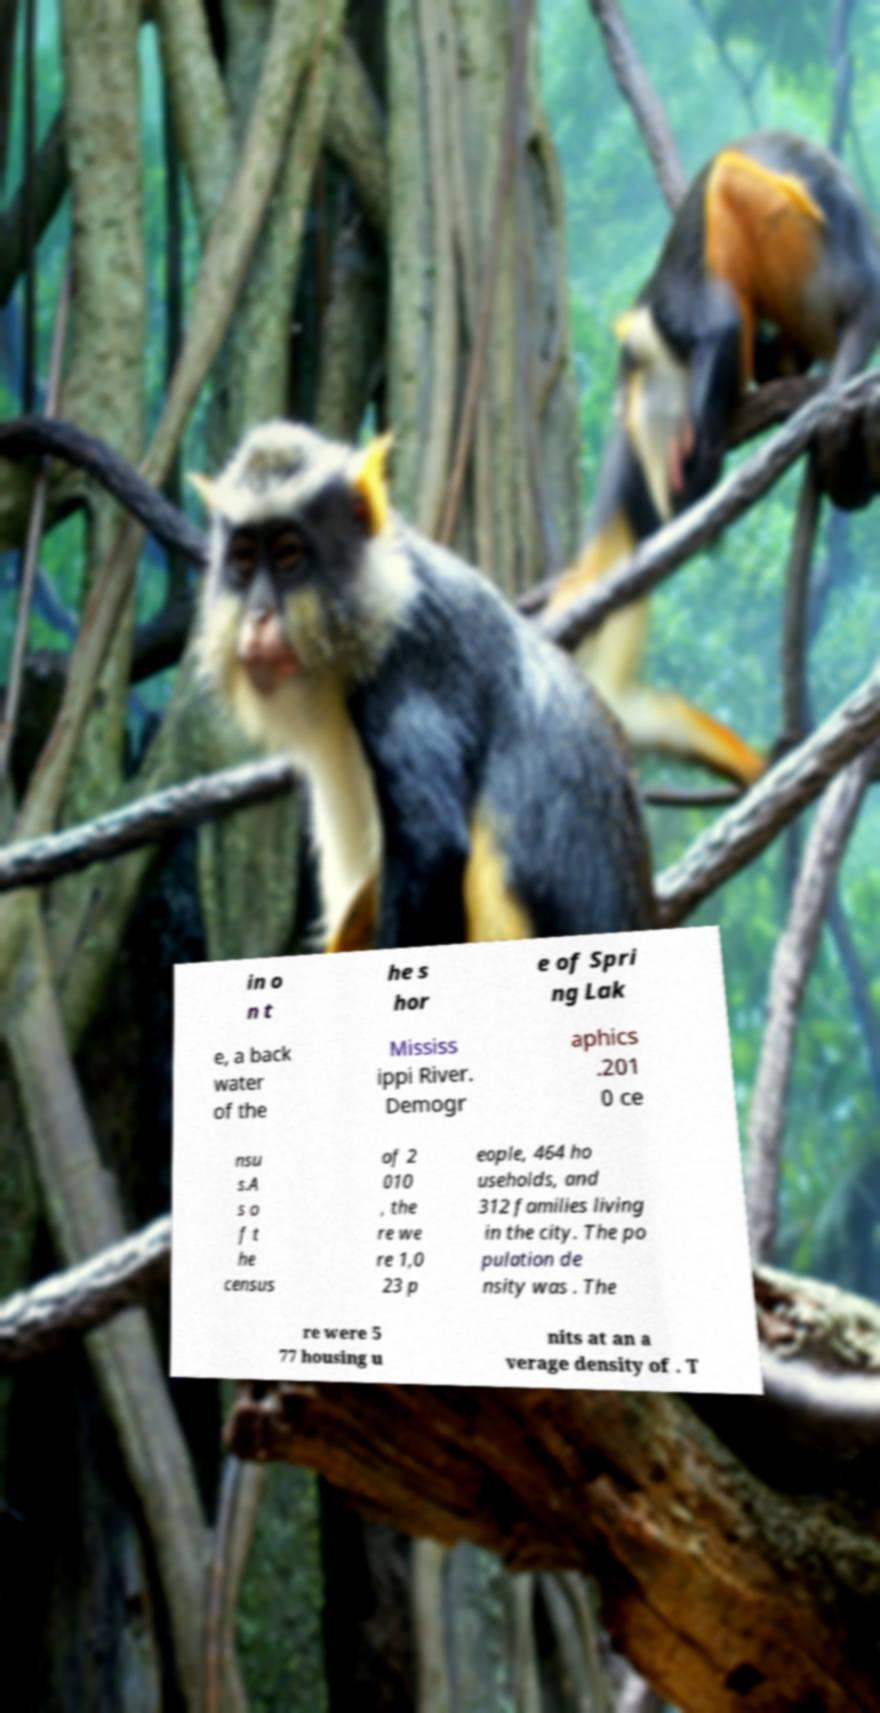I need the written content from this picture converted into text. Can you do that? in o n t he s hor e of Spri ng Lak e, a back water of the Mississ ippi River. Demogr aphics .201 0 ce nsu s.A s o f t he census of 2 010 , the re we re 1,0 23 p eople, 464 ho useholds, and 312 families living in the city. The po pulation de nsity was . The re were 5 77 housing u nits at an a verage density of . T 